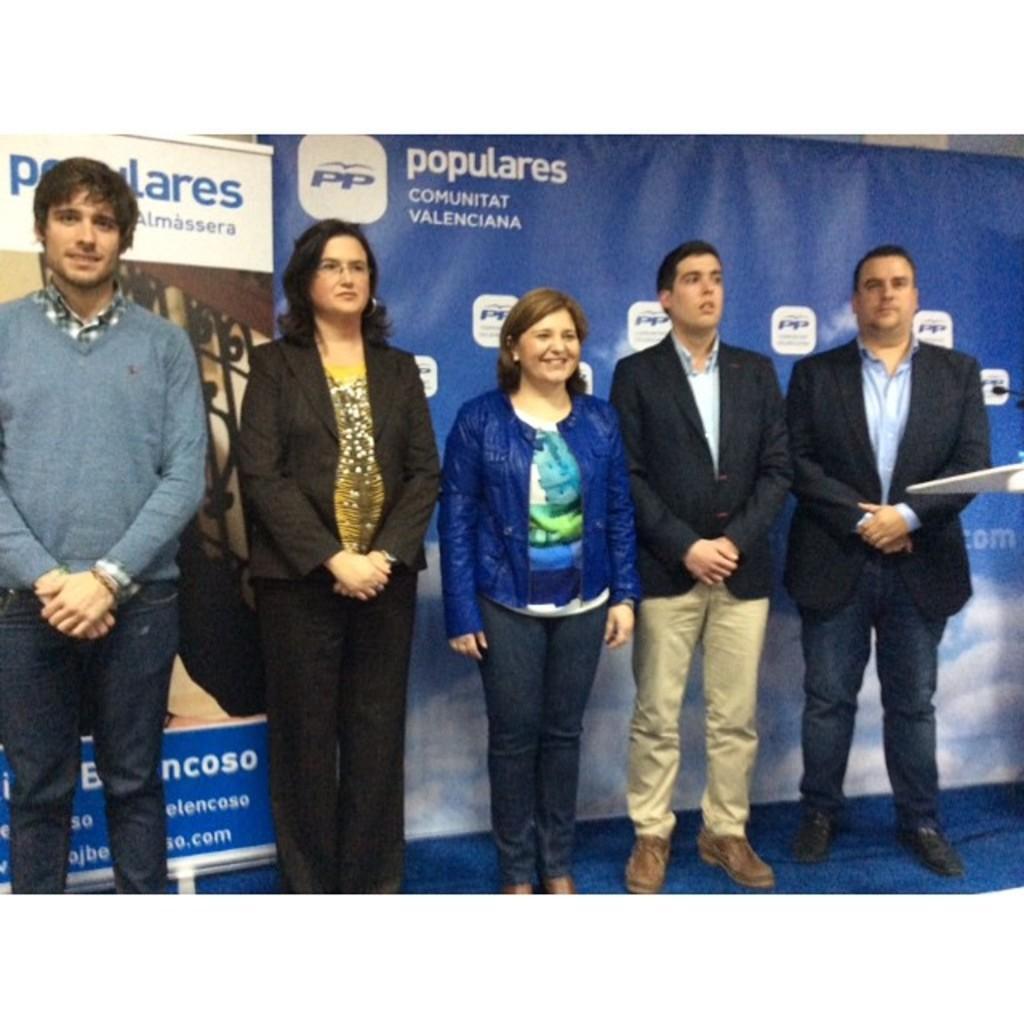Describe this image in one or two sentences. In the center of the picture there are people standing on the stage, behind them there are banners. On the right there is a podium and a mic. 